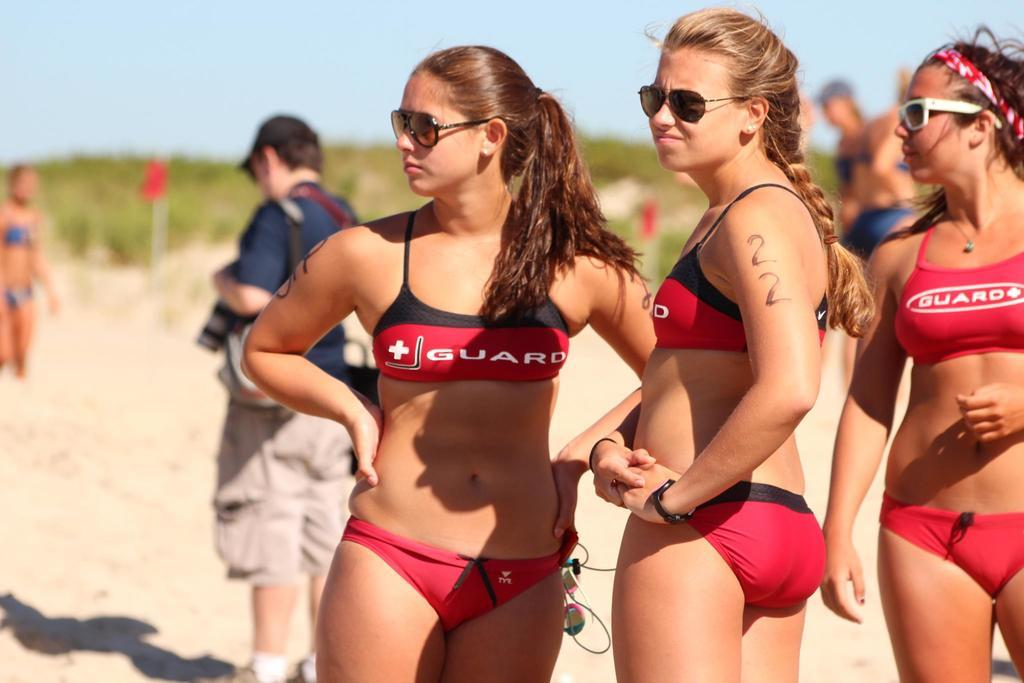How many people are in the image? There is a group of people standing in the image, but the exact number cannot be determined from the provided facts. What else can be seen in the image besides the group of people? Plants, flags, the sky, and sand are visible in the image. What is the color of the sky in the image? The sky is visible at the top of the image, but the color cannot be determined from the provided facts. What type of surface is visible at the bottom of the image? There is sand visible at the bottom of the image. What type of popcorn is being served at the event in the image? There is no mention of an event or popcorn in the image, so it cannot be determined from the provided facts. 